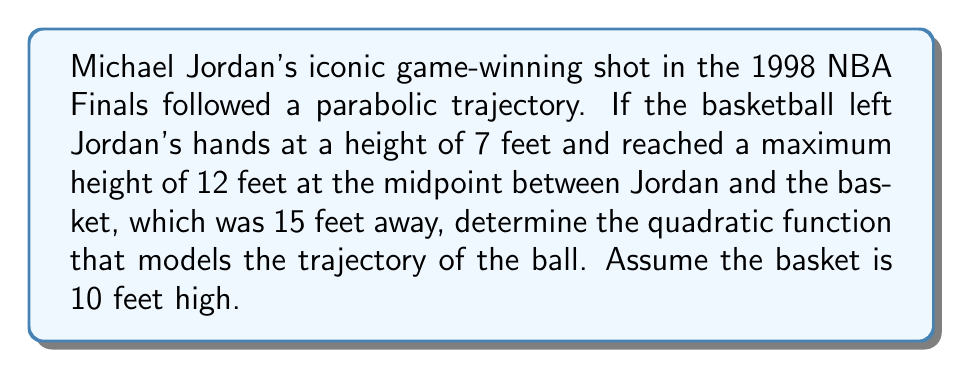Show me your answer to this math problem. Let's approach this step-by-step:

1) The general form of a quadratic function is $f(x) = ax^2 + bx + c$, where $a$, $b$, and $c$ are constants and $a \neq 0$.

2) We know three points on this parabola:
   - Start: (0, 7) - Jordan released the ball at x = 0, y = 7
   - Peak: (7.5, 12) - Midpoint between Jordan and basket, maximum height
   - End: (15, 10) - The basket is 15 feet away and 10 feet high

3) Let's substitute these points into our general equation:
   (0, 7):   $7 = a(0)^2 + b(0) + c$, so $c = 7$
   (7.5, 12): $12 = a(7.5)^2 + b(7.5) + 7$
   (15, 10):  $10 = a(15)^2 + b(15) + 7$

4) From the first equation, we know $c = 7$. Let's subtract this from the other two equations:
   $5 = a(7.5)^2 + b(7.5)$
   $3 = a(15)^2 + b(15)$

5) Now, let's subtract the second equation from twice the first equation to eliminate $b$:
   $10 = a(7.5)^2 + b(7.5)$
   $6 = a(15)^2 + b(15)$
   $4 = a(7.5)^2 - a(15)^2 + b(7.5) - b(15)$
   $4 = a(56.25 - 225) + 7.5b - 15b$
   $4 = -168.75a - 7.5b$

6) Solve for $b$ in terms of $a$:
   $-7.5b = 4 + 168.75a$
   $b = -\frac{4 + 168.75a}{7.5} = -0.533 - 22.5a$

7) Substitute this back into one of our original equations:
   $5 = a(7.5)^2 + (-0.533 - 22.5a)(7.5)$
   $5 = 56.25a - 4 - 168.75a$
   $9 = -112.5a$
   $a = -0.08$

8) Now we can find $b$:
   $b = -0.533 - 22.5(-0.08) = 1.267$

Therefore, the quadratic function is:
$$f(x) = -0.08x^2 + 1.267x + 7$$
Answer: $f(x) = -0.08x^2 + 1.267x + 7$ 